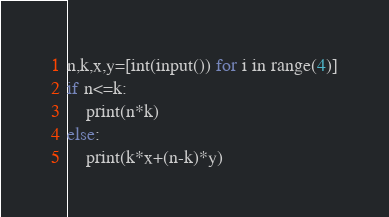Convert code to text. <code><loc_0><loc_0><loc_500><loc_500><_Python_>n,k,x,y=[int(input()) for i in range(4)]
if n<=k:
    print(n*k)
else:
    print(k*x+(n-k)*y)</code> 